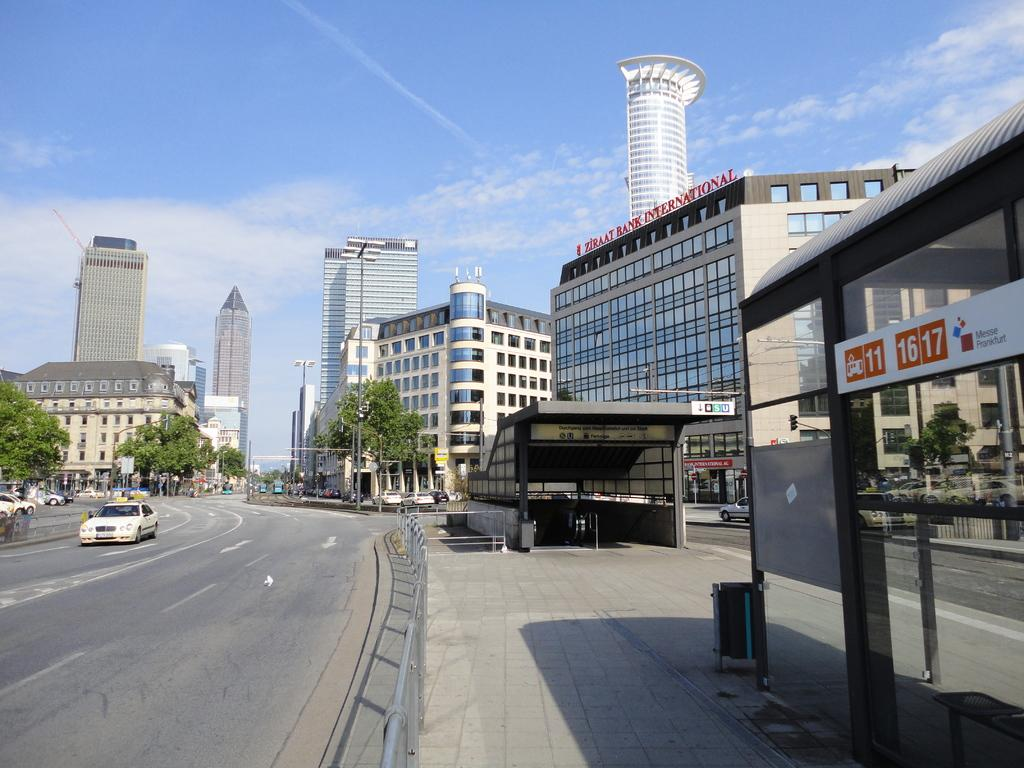What type of structures can be seen in the image? There are buildings in the image. What other natural or man-made elements can be seen in the image? There are trees, light poles, vehicles on the road, railings, sheds, and an object on the pavement visible in the image. What is visible in the background of the image? The sky is visible in the background of the image, with clouds present. What type of floor can be seen in the image? There is no floor visible in the image; it primarily features outdoor elements such as buildings, trees, and vehicles on the road. What color is the thread used to sew the dime in the image? There is no thread or dime present in the image. 